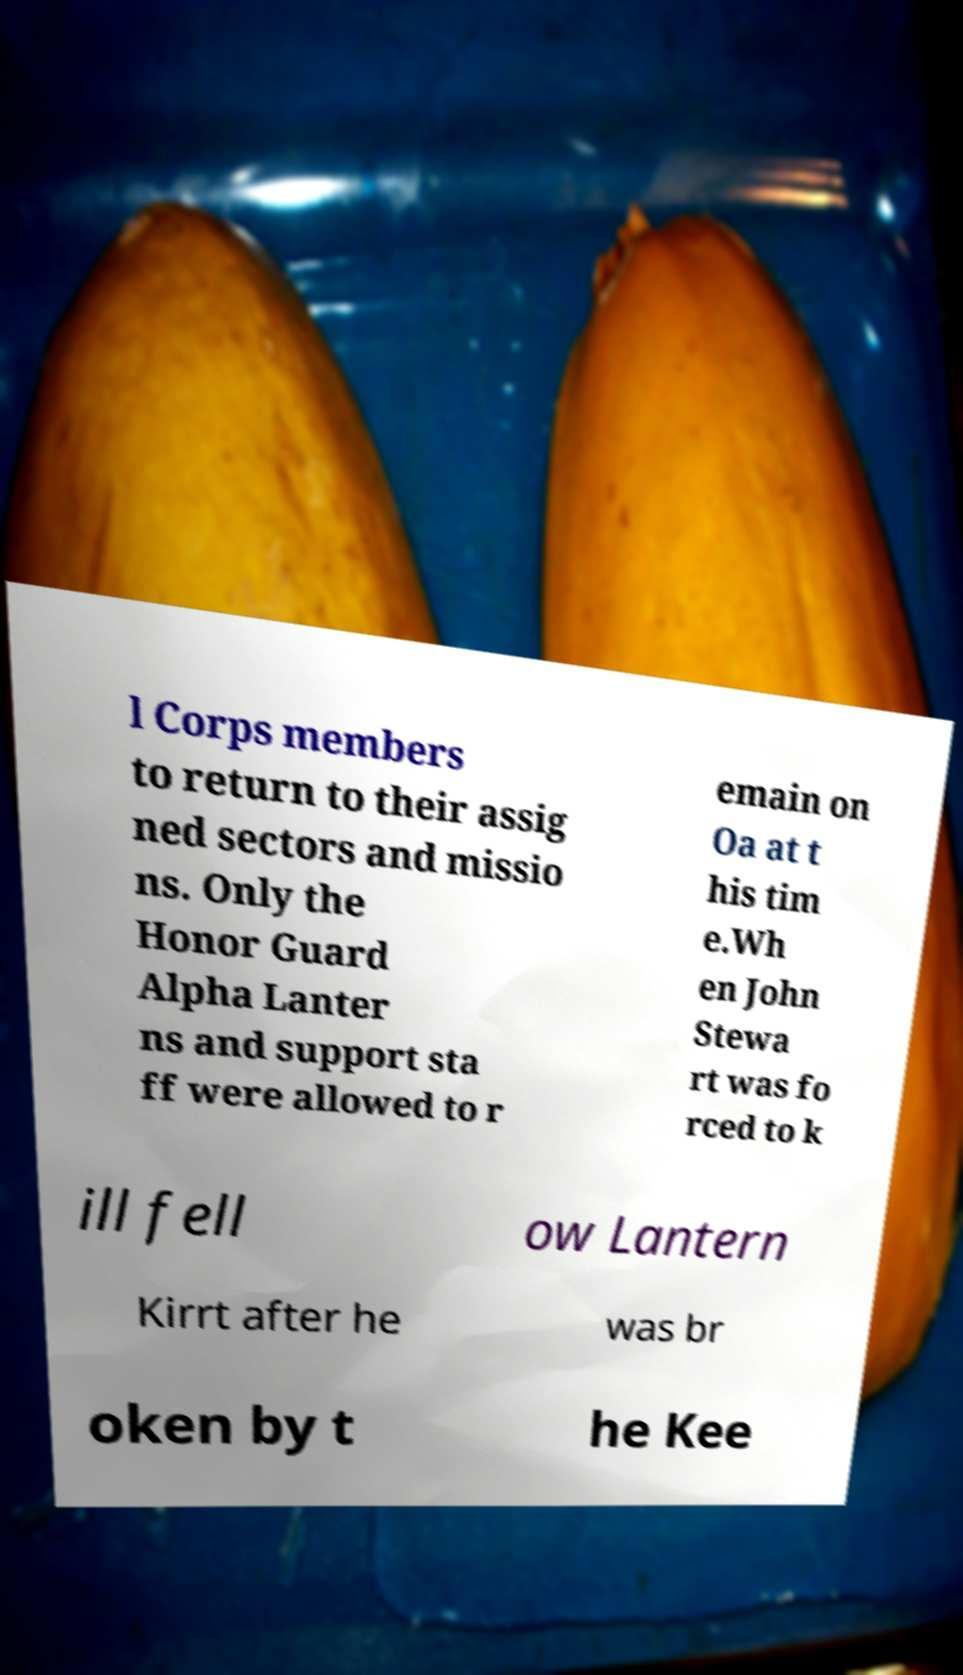I need the written content from this picture converted into text. Can you do that? l Corps members to return to their assig ned sectors and missio ns. Only the Honor Guard Alpha Lanter ns and support sta ff were allowed to r emain on Oa at t his tim e.Wh en John Stewa rt was fo rced to k ill fell ow Lantern Kirrt after he was br oken by t he Kee 